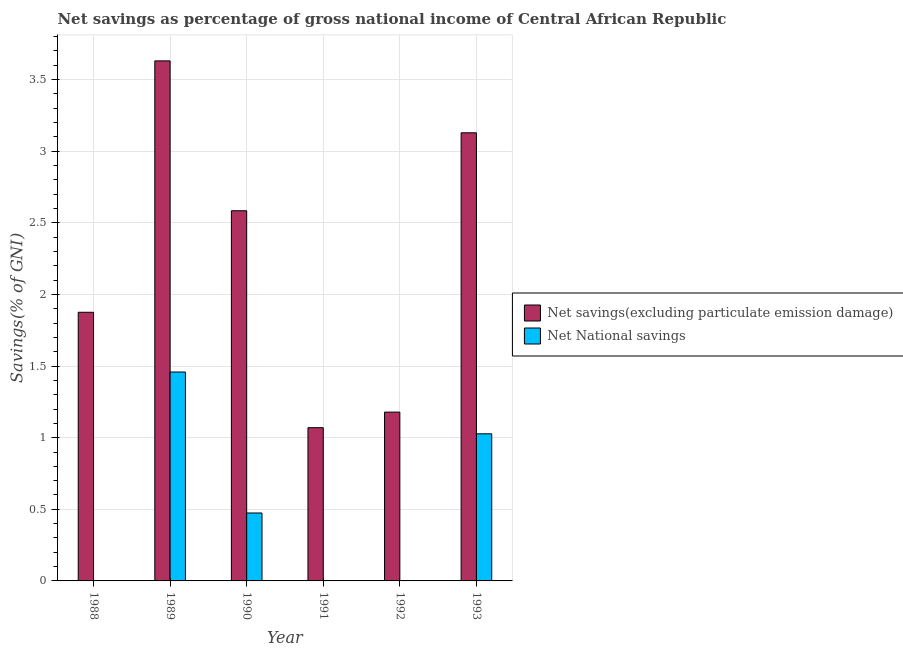Are the number of bars on each tick of the X-axis equal?
Provide a succinct answer. No. How many bars are there on the 1st tick from the left?
Ensure brevity in your answer.  1. In how many cases, is the number of bars for a given year not equal to the number of legend labels?
Your response must be concise. 3. What is the net national savings in 1993?
Your answer should be very brief. 1.03. Across all years, what is the maximum net national savings?
Your answer should be very brief. 1.46. Across all years, what is the minimum net savings(excluding particulate emission damage)?
Your response must be concise. 1.07. What is the total net savings(excluding particulate emission damage) in the graph?
Provide a short and direct response. 13.47. What is the difference between the net savings(excluding particulate emission damage) in 1988 and that in 1992?
Your answer should be very brief. 0.7. What is the difference between the net savings(excluding particulate emission damage) in 1989 and the net national savings in 1993?
Provide a short and direct response. 0.5. What is the average net national savings per year?
Your response must be concise. 0.49. In the year 1989, what is the difference between the net savings(excluding particulate emission damage) and net national savings?
Keep it short and to the point. 0. In how many years, is the net national savings greater than 0.7 %?
Provide a succinct answer. 2. What is the ratio of the net savings(excluding particulate emission damage) in 1988 to that in 1990?
Provide a short and direct response. 0.73. What is the difference between the highest and the second highest net savings(excluding particulate emission damage)?
Offer a very short reply. 0.5. What is the difference between the highest and the lowest net national savings?
Your response must be concise. 1.46. Is the sum of the net savings(excluding particulate emission damage) in 1988 and 1992 greater than the maximum net national savings across all years?
Offer a terse response. No. How many bars are there?
Keep it short and to the point. 9. Are all the bars in the graph horizontal?
Make the answer very short. No. What is the difference between two consecutive major ticks on the Y-axis?
Provide a short and direct response. 0.5. Are the values on the major ticks of Y-axis written in scientific E-notation?
Keep it short and to the point. No. Does the graph contain any zero values?
Your answer should be very brief. Yes. Where does the legend appear in the graph?
Offer a terse response. Center right. How many legend labels are there?
Provide a succinct answer. 2. How are the legend labels stacked?
Make the answer very short. Vertical. What is the title of the graph?
Provide a short and direct response. Net savings as percentage of gross national income of Central African Republic. What is the label or title of the Y-axis?
Keep it short and to the point. Savings(% of GNI). What is the Savings(% of GNI) in Net savings(excluding particulate emission damage) in 1988?
Your answer should be very brief. 1.88. What is the Savings(% of GNI) of Net National savings in 1988?
Your answer should be compact. 0. What is the Savings(% of GNI) in Net savings(excluding particulate emission damage) in 1989?
Ensure brevity in your answer.  3.63. What is the Savings(% of GNI) of Net National savings in 1989?
Ensure brevity in your answer.  1.46. What is the Savings(% of GNI) in Net savings(excluding particulate emission damage) in 1990?
Give a very brief answer. 2.58. What is the Savings(% of GNI) of Net National savings in 1990?
Provide a succinct answer. 0.47. What is the Savings(% of GNI) in Net savings(excluding particulate emission damage) in 1991?
Offer a terse response. 1.07. What is the Savings(% of GNI) in Net National savings in 1991?
Give a very brief answer. 0. What is the Savings(% of GNI) of Net savings(excluding particulate emission damage) in 1992?
Provide a succinct answer. 1.18. What is the Savings(% of GNI) of Net National savings in 1992?
Your response must be concise. 0. What is the Savings(% of GNI) in Net savings(excluding particulate emission damage) in 1993?
Offer a terse response. 3.13. What is the Savings(% of GNI) in Net National savings in 1993?
Offer a terse response. 1.03. Across all years, what is the maximum Savings(% of GNI) of Net savings(excluding particulate emission damage)?
Your answer should be very brief. 3.63. Across all years, what is the maximum Savings(% of GNI) in Net National savings?
Provide a short and direct response. 1.46. Across all years, what is the minimum Savings(% of GNI) of Net savings(excluding particulate emission damage)?
Offer a terse response. 1.07. What is the total Savings(% of GNI) of Net savings(excluding particulate emission damage) in the graph?
Your answer should be compact. 13.47. What is the total Savings(% of GNI) of Net National savings in the graph?
Give a very brief answer. 2.96. What is the difference between the Savings(% of GNI) in Net savings(excluding particulate emission damage) in 1988 and that in 1989?
Give a very brief answer. -1.76. What is the difference between the Savings(% of GNI) in Net savings(excluding particulate emission damage) in 1988 and that in 1990?
Make the answer very short. -0.71. What is the difference between the Savings(% of GNI) in Net savings(excluding particulate emission damage) in 1988 and that in 1991?
Your response must be concise. 0.81. What is the difference between the Savings(% of GNI) in Net savings(excluding particulate emission damage) in 1988 and that in 1992?
Your response must be concise. 0.7. What is the difference between the Savings(% of GNI) in Net savings(excluding particulate emission damage) in 1988 and that in 1993?
Provide a succinct answer. -1.25. What is the difference between the Savings(% of GNI) of Net savings(excluding particulate emission damage) in 1989 and that in 1990?
Your answer should be compact. 1.05. What is the difference between the Savings(% of GNI) in Net National savings in 1989 and that in 1990?
Keep it short and to the point. 0.98. What is the difference between the Savings(% of GNI) of Net savings(excluding particulate emission damage) in 1989 and that in 1991?
Offer a very short reply. 2.56. What is the difference between the Savings(% of GNI) in Net savings(excluding particulate emission damage) in 1989 and that in 1992?
Give a very brief answer. 2.45. What is the difference between the Savings(% of GNI) in Net savings(excluding particulate emission damage) in 1989 and that in 1993?
Your answer should be compact. 0.5. What is the difference between the Savings(% of GNI) of Net National savings in 1989 and that in 1993?
Provide a succinct answer. 0.43. What is the difference between the Savings(% of GNI) of Net savings(excluding particulate emission damage) in 1990 and that in 1991?
Your answer should be compact. 1.51. What is the difference between the Savings(% of GNI) in Net savings(excluding particulate emission damage) in 1990 and that in 1992?
Your answer should be compact. 1.41. What is the difference between the Savings(% of GNI) in Net savings(excluding particulate emission damage) in 1990 and that in 1993?
Ensure brevity in your answer.  -0.54. What is the difference between the Savings(% of GNI) in Net National savings in 1990 and that in 1993?
Offer a very short reply. -0.55. What is the difference between the Savings(% of GNI) in Net savings(excluding particulate emission damage) in 1991 and that in 1992?
Give a very brief answer. -0.11. What is the difference between the Savings(% of GNI) in Net savings(excluding particulate emission damage) in 1991 and that in 1993?
Keep it short and to the point. -2.06. What is the difference between the Savings(% of GNI) in Net savings(excluding particulate emission damage) in 1992 and that in 1993?
Offer a very short reply. -1.95. What is the difference between the Savings(% of GNI) of Net savings(excluding particulate emission damage) in 1988 and the Savings(% of GNI) of Net National savings in 1989?
Provide a succinct answer. 0.42. What is the difference between the Savings(% of GNI) in Net savings(excluding particulate emission damage) in 1988 and the Savings(% of GNI) in Net National savings in 1990?
Your answer should be compact. 1.4. What is the difference between the Savings(% of GNI) in Net savings(excluding particulate emission damage) in 1988 and the Savings(% of GNI) in Net National savings in 1993?
Provide a short and direct response. 0.85. What is the difference between the Savings(% of GNI) of Net savings(excluding particulate emission damage) in 1989 and the Savings(% of GNI) of Net National savings in 1990?
Ensure brevity in your answer.  3.16. What is the difference between the Savings(% of GNI) in Net savings(excluding particulate emission damage) in 1989 and the Savings(% of GNI) in Net National savings in 1993?
Your answer should be compact. 2.6. What is the difference between the Savings(% of GNI) of Net savings(excluding particulate emission damage) in 1990 and the Savings(% of GNI) of Net National savings in 1993?
Ensure brevity in your answer.  1.56. What is the difference between the Savings(% of GNI) of Net savings(excluding particulate emission damage) in 1991 and the Savings(% of GNI) of Net National savings in 1993?
Offer a very short reply. 0.04. What is the difference between the Savings(% of GNI) of Net savings(excluding particulate emission damage) in 1992 and the Savings(% of GNI) of Net National savings in 1993?
Give a very brief answer. 0.15. What is the average Savings(% of GNI) of Net savings(excluding particulate emission damage) per year?
Your answer should be compact. 2.24. What is the average Savings(% of GNI) of Net National savings per year?
Your answer should be compact. 0.49. In the year 1989, what is the difference between the Savings(% of GNI) in Net savings(excluding particulate emission damage) and Savings(% of GNI) in Net National savings?
Give a very brief answer. 2.17. In the year 1990, what is the difference between the Savings(% of GNI) of Net savings(excluding particulate emission damage) and Savings(% of GNI) of Net National savings?
Give a very brief answer. 2.11. In the year 1993, what is the difference between the Savings(% of GNI) in Net savings(excluding particulate emission damage) and Savings(% of GNI) in Net National savings?
Offer a terse response. 2.1. What is the ratio of the Savings(% of GNI) of Net savings(excluding particulate emission damage) in 1988 to that in 1989?
Offer a terse response. 0.52. What is the ratio of the Savings(% of GNI) in Net savings(excluding particulate emission damage) in 1988 to that in 1990?
Give a very brief answer. 0.73. What is the ratio of the Savings(% of GNI) in Net savings(excluding particulate emission damage) in 1988 to that in 1991?
Your response must be concise. 1.75. What is the ratio of the Savings(% of GNI) of Net savings(excluding particulate emission damage) in 1988 to that in 1992?
Make the answer very short. 1.59. What is the ratio of the Savings(% of GNI) of Net savings(excluding particulate emission damage) in 1988 to that in 1993?
Give a very brief answer. 0.6. What is the ratio of the Savings(% of GNI) of Net savings(excluding particulate emission damage) in 1989 to that in 1990?
Give a very brief answer. 1.4. What is the ratio of the Savings(% of GNI) of Net National savings in 1989 to that in 1990?
Provide a short and direct response. 3.08. What is the ratio of the Savings(% of GNI) in Net savings(excluding particulate emission damage) in 1989 to that in 1991?
Provide a short and direct response. 3.39. What is the ratio of the Savings(% of GNI) in Net savings(excluding particulate emission damage) in 1989 to that in 1992?
Provide a succinct answer. 3.08. What is the ratio of the Savings(% of GNI) of Net savings(excluding particulate emission damage) in 1989 to that in 1993?
Provide a succinct answer. 1.16. What is the ratio of the Savings(% of GNI) in Net National savings in 1989 to that in 1993?
Provide a short and direct response. 1.42. What is the ratio of the Savings(% of GNI) of Net savings(excluding particulate emission damage) in 1990 to that in 1991?
Provide a succinct answer. 2.42. What is the ratio of the Savings(% of GNI) in Net savings(excluding particulate emission damage) in 1990 to that in 1992?
Your answer should be compact. 2.19. What is the ratio of the Savings(% of GNI) in Net savings(excluding particulate emission damage) in 1990 to that in 1993?
Ensure brevity in your answer.  0.83. What is the ratio of the Savings(% of GNI) in Net National savings in 1990 to that in 1993?
Make the answer very short. 0.46. What is the ratio of the Savings(% of GNI) in Net savings(excluding particulate emission damage) in 1991 to that in 1992?
Offer a very short reply. 0.91. What is the ratio of the Savings(% of GNI) of Net savings(excluding particulate emission damage) in 1991 to that in 1993?
Provide a succinct answer. 0.34. What is the ratio of the Savings(% of GNI) of Net savings(excluding particulate emission damage) in 1992 to that in 1993?
Provide a succinct answer. 0.38. What is the difference between the highest and the second highest Savings(% of GNI) of Net savings(excluding particulate emission damage)?
Make the answer very short. 0.5. What is the difference between the highest and the second highest Savings(% of GNI) in Net National savings?
Offer a very short reply. 0.43. What is the difference between the highest and the lowest Savings(% of GNI) in Net savings(excluding particulate emission damage)?
Your answer should be compact. 2.56. What is the difference between the highest and the lowest Savings(% of GNI) in Net National savings?
Keep it short and to the point. 1.46. 